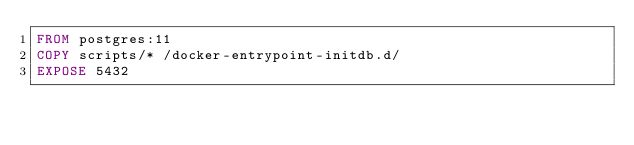<code> <loc_0><loc_0><loc_500><loc_500><_Dockerfile_>FROM postgres:11
COPY scripts/* /docker-entrypoint-initdb.d/
EXPOSE 5432
</code> 